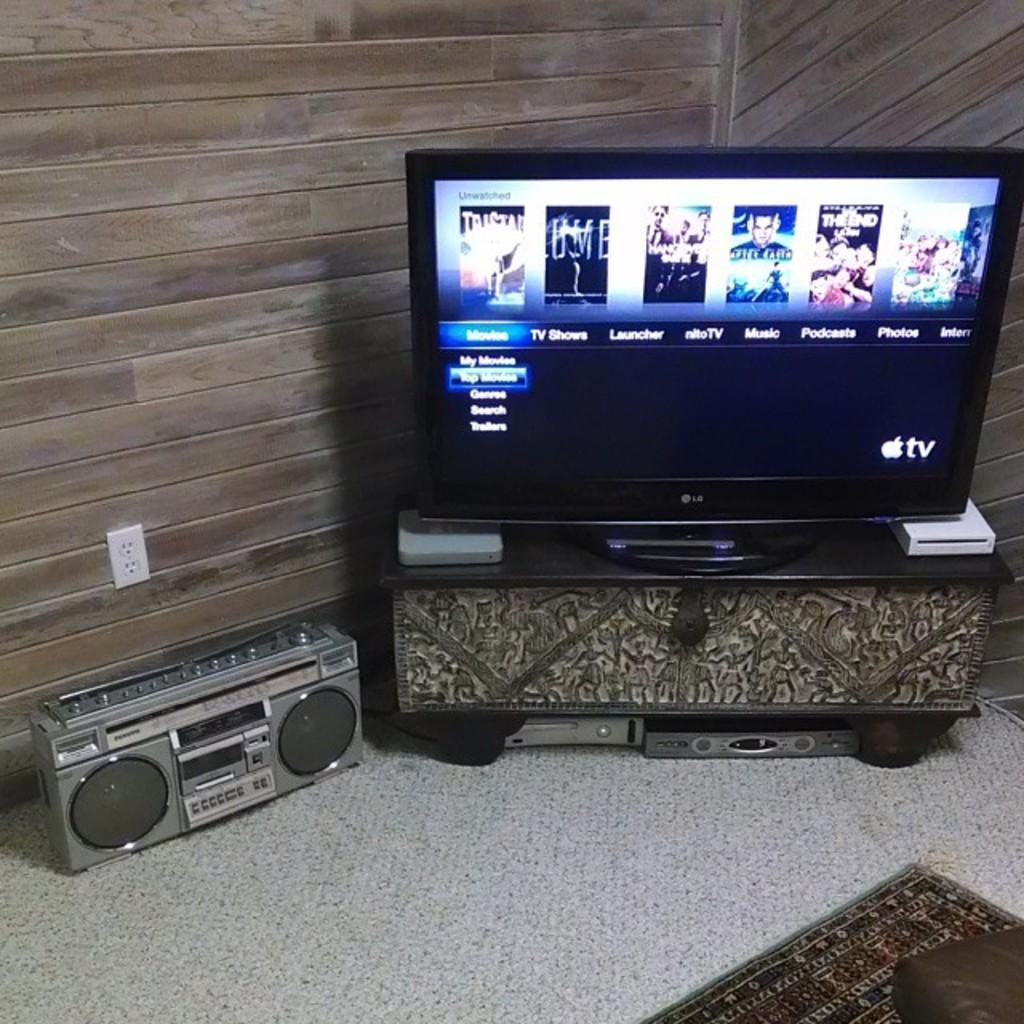<image>
Give a short and clear explanation of the subsequent image. Apple TV running on a television set showing top movies 